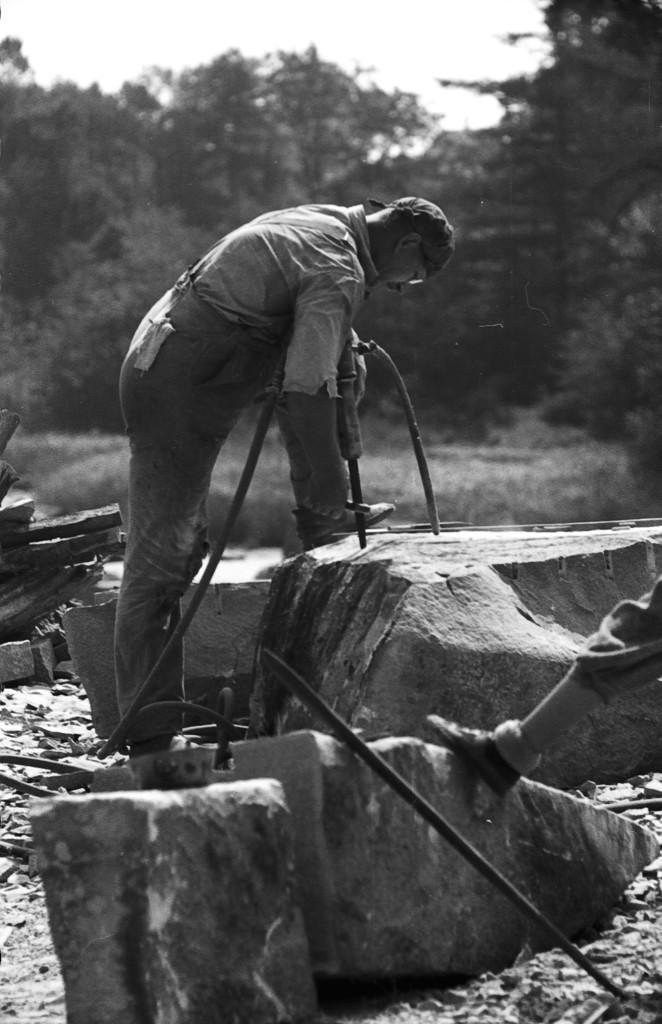Please provide a concise description of this image. In this picture we can see the leg of a person, stones and some objects. We can see a person holding an object. There are a few plants and trees are visible in the background. 